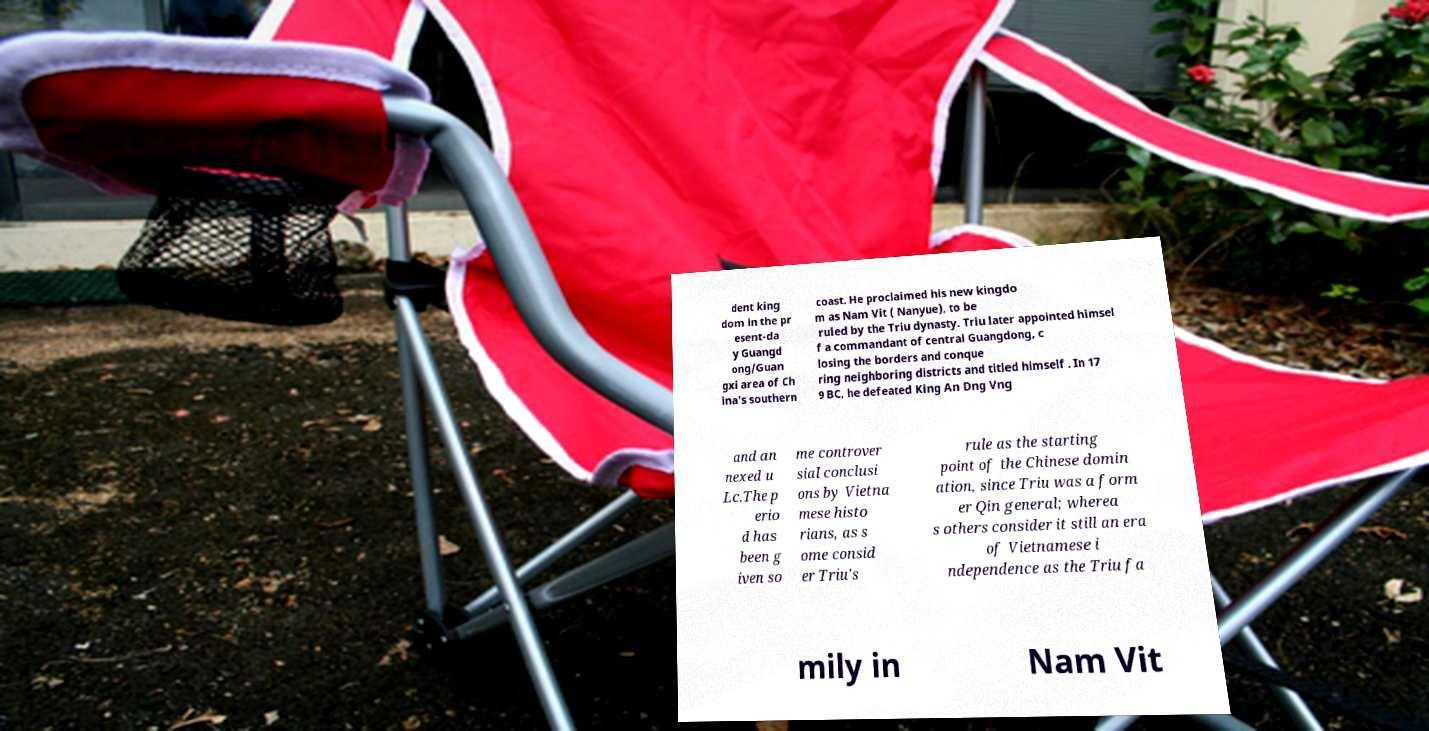Could you extract and type out the text from this image? dent king dom in the pr esent-da y Guangd ong/Guan gxi area of Ch ina's southern coast. He proclaimed his new kingdo m as Nam Vit ( Nanyue), to be ruled by the Triu dynasty. Triu later appointed himsel f a commandant of central Guangdong, c losing the borders and conque ring neighboring districts and titled himself . In 17 9 BC, he defeated King An Dng Vng and an nexed u Lc.The p erio d has been g iven so me controver sial conclusi ons by Vietna mese histo rians, as s ome consid er Triu's rule as the starting point of the Chinese domin ation, since Triu was a form er Qin general; wherea s others consider it still an era of Vietnamese i ndependence as the Triu fa mily in Nam Vit 